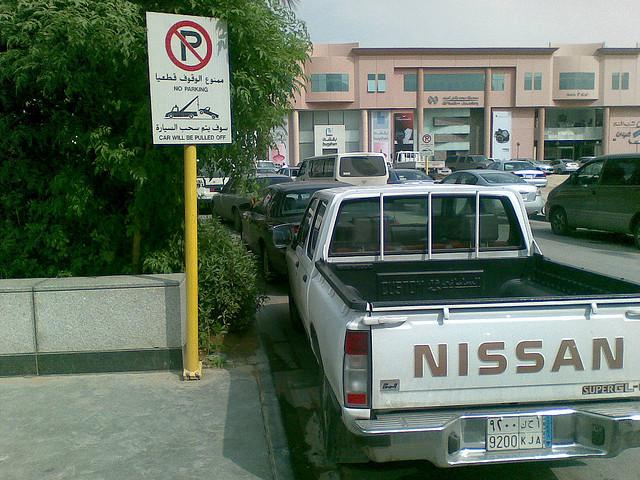Does the white truck have an Arabic tag?
Quick response, please. No. What is the car's unit number?
Answer briefly. 9200. What specific model is the truck?
Answer briefly. Nissan. How long can you park at this meter?
Keep it brief. 1 hour. What are hanging on the truck?
Be succinct. Nothing. What auto maker makes the minivan?
Quick response, please. Nissan. What brand is the truck?
Be succinct. Nissan. 